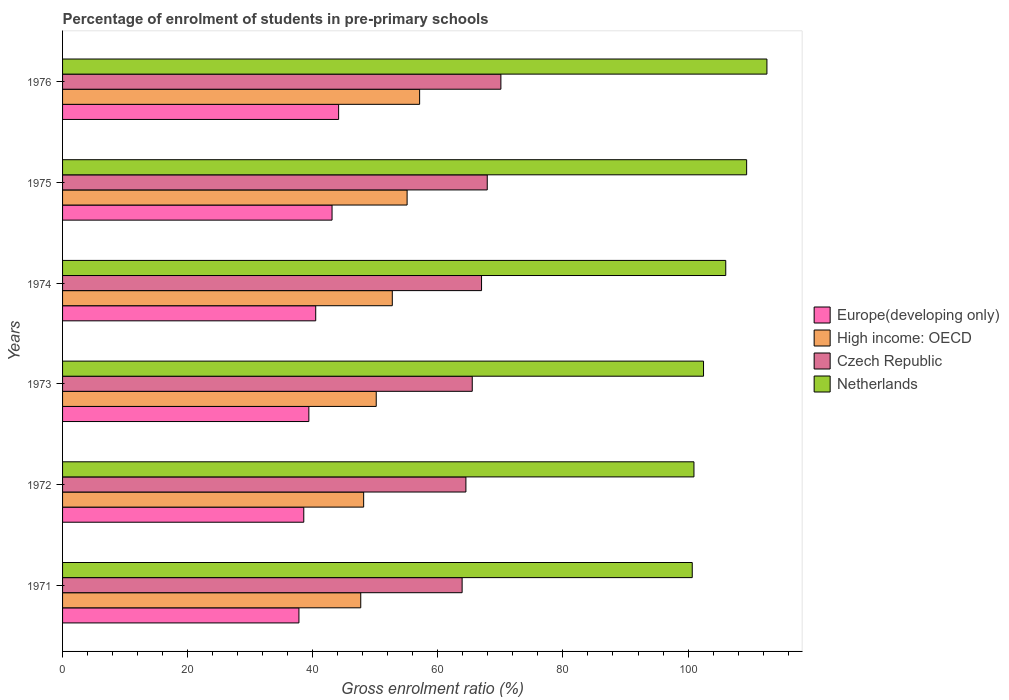How many different coloured bars are there?
Offer a very short reply. 4. How many groups of bars are there?
Your answer should be very brief. 6. Are the number of bars on each tick of the Y-axis equal?
Your answer should be compact. Yes. How many bars are there on the 4th tick from the bottom?
Your response must be concise. 4. What is the percentage of students enrolled in pre-primary schools in Europe(developing only) in 1972?
Offer a terse response. 38.57. Across all years, what is the maximum percentage of students enrolled in pre-primary schools in Czech Republic?
Your answer should be compact. 70.08. Across all years, what is the minimum percentage of students enrolled in pre-primary schools in Europe(developing only)?
Offer a terse response. 37.79. In which year was the percentage of students enrolled in pre-primary schools in Netherlands maximum?
Keep it short and to the point. 1976. In which year was the percentage of students enrolled in pre-primary schools in Europe(developing only) minimum?
Provide a succinct answer. 1971. What is the total percentage of students enrolled in pre-primary schools in Czech Republic in the graph?
Keep it short and to the point. 398.83. What is the difference between the percentage of students enrolled in pre-primary schools in Czech Republic in 1973 and that in 1976?
Your answer should be very brief. -4.58. What is the difference between the percentage of students enrolled in pre-primary schools in Netherlands in 1973 and the percentage of students enrolled in pre-primary schools in High income: OECD in 1974?
Give a very brief answer. 49.76. What is the average percentage of students enrolled in pre-primary schools in High income: OECD per year?
Offer a very short reply. 51.81. In the year 1974, what is the difference between the percentage of students enrolled in pre-primary schools in High income: OECD and percentage of students enrolled in pre-primary schools in Czech Republic?
Provide a short and direct response. -14.27. In how many years, is the percentage of students enrolled in pre-primary schools in Netherlands greater than 12 %?
Your answer should be compact. 6. What is the ratio of the percentage of students enrolled in pre-primary schools in Czech Republic in 1972 to that in 1975?
Ensure brevity in your answer.  0.95. What is the difference between the highest and the second highest percentage of students enrolled in pre-primary schools in Netherlands?
Provide a short and direct response. 3.24. What is the difference between the highest and the lowest percentage of students enrolled in pre-primary schools in Netherlands?
Provide a succinct answer. 11.94. Is the sum of the percentage of students enrolled in pre-primary schools in Netherlands in 1972 and 1975 greater than the maximum percentage of students enrolled in pre-primary schools in Czech Republic across all years?
Your answer should be very brief. Yes. What does the 1st bar from the top in 1974 represents?
Offer a terse response. Netherlands. Is it the case that in every year, the sum of the percentage of students enrolled in pre-primary schools in Europe(developing only) and percentage of students enrolled in pre-primary schools in High income: OECD is greater than the percentage of students enrolled in pre-primary schools in Netherlands?
Your response must be concise. No. How many bars are there?
Provide a succinct answer. 24. What is the difference between two consecutive major ticks on the X-axis?
Offer a terse response. 20. Does the graph contain any zero values?
Your answer should be compact. No. Does the graph contain grids?
Your response must be concise. No. Where does the legend appear in the graph?
Keep it short and to the point. Center right. What is the title of the graph?
Make the answer very short. Percentage of enrolment of students in pre-primary schools. What is the label or title of the Y-axis?
Your answer should be compact. Years. What is the Gross enrolment ratio (%) in Europe(developing only) in 1971?
Your response must be concise. 37.79. What is the Gross enrolment ratio (%) of High income: OECD in 1971?
Offer a very short reply. 47.67. What is the Gross enrolment ratio (%) in Czech Republic in 1971?
Give a very brief answer. 63.88. What is the Gross enrolment ratio (%) of Netherlands in 1971?
Keep it short and to the point. 100.67. What is the Gross enrolment ratio (%) of Europe(developing only) in 1972?
Offer a terse response. 38.57. What is the Gross enrolment ratio (%) of High income: OECD in 1972?
Offer a terse response. 48.14. What is the Gross enrolment ratio (%) of Czech Republic in 1972?
Keep it short and to the point. 64.48. What is the Gross enrolment ratio (%) of Netherlands in 1972?
Provide a short and direct response. 100.94. What is the Gross enrolment ratio (%) of Europe(developing only) in 1973?
Make the answer very short. 39.38. What is the Gross enrolment ratio (%) in High income: OECD in 1973?
Your response must be concise. 50.15. What is the Gross enrolment ratio (%) in Czech Republic in 1973?
Provide a short and direct response. 65.5. What is the Gross enrolment ratio (%) of Netherlands in 1973?
Offer a terse response. 102.47. What is the Gross enrolment ratio (%) in Europe(developing only) in 1974?
Your answer should be compact. 40.47. What is the Gross enrolment ratio (%) in High income: OECD in 1974?
Your answer should be compact. 52.72. What is the Gross enrolment ratio (%) of Czech Republic in 1974?
Your response must be concise. 66.99. What is the Gross enrolment ratio (%) of Netherlands in 1974?
Ensure brevity in your answer.  106.03. What is the Gross enrolment ratio (%) of Europe(developing only) in 1975?
Offer a terse response. 43.08. What is the Gross enrolment ratio (%) of High income: OECD in 1975?
Provide a short and direct response. 55.08. What is the Gross enrolment ratio (%) of Czech Republic in 1975?
Your answer should be compact. 67.9. What is the Gross enrolment ratio (%) in Netherlands in 1975?
Your answer should be compact. 109.37. What is the Gross enrolment ratio (%) of Europe(developing only) in 1976?
Ensure brevity in your answer.  44.14. What is the Gross enrolment ratio (%) in High income: OECD in 1976?
Give a very brief answer. 57.09. What is the Gross enrolment ratio (%) of Czech Republic in 1976?
Provide a short and direct response. 70.08. What is the Gross enrolment ratio (%) of Netherlands in 1976?
Make the answer very short. 112.61. Across all years, what is the maximum Gross enrolment ratio (%) in Europe(developing only)?
Offer a terse response. 44.14. Across all years, what is the maximum Gross enrolment ratio (%) in High income: OECD?
Offer a very short reply. 57.09. Across all years, what is the maximum Gross enrolment ratio (%) of Czech Republic?
Make the answer very short. 70.08. Across all years, what is the maximum Gross enrolment ratio (%) of Netherlands?
Offer a very short reply. 112.61. Across all years, what is the minimum Gross enrolment ratio (%) of Europe(developing only)?
Offer a terse response. 37.79. Across all years, what is the minimum Gross enrolment ratio (%) of High income: OECD?
Give a very brief answer. 47.67. Across all years, what is the minimum Gross enrolment ratio (%) of Czech Republic?
Your answer should be very brief. 63.88. Across all years, what is the minimum Gross enrolment ratio (%) of Netherlands?
Provide a succinct answer. 100.67. What is the total Gross enrolment ratio (%) in Europe(developing only) in the graph?
Ensure brevity in your answer.  243.43. What is the total Gross enrolment ratio (%) of High income: OECD in the graph?
Provide a short and direct response. 310.85. What is the total Gross enrolment ratio (%) of Czech Republic in the graph?
Your response must be concise. 398.83. What is the total Gross enrolment ratio (%) of Netherlands in the graph?
Offer a very short reply. 632.09. What is the difference between the Gross enrolment ratio (%) of Europe(developing only) in 1971 and that in 1972?
Give a very brief answer. -0.78. What is the difference between the Gross enrolment ratio (%) in High income: OECD in 1971 and that in 1972?
Your answer should be compact. -0.47. What is the difference between the Gross enrolment ratio (%) of Czech Republic in 1971 and that in 1972?
Make the answer very short. -0.6. What is the difference between the Gross enrolment ratio (%) of Netherlands in 1971 and that in 1972?
Offer a terse response. -0.27. What is the difference between the Gross enrolment ratio (%) in Europe(developing only) in 1971 and that in 1973?
Keep it short and to the point. -1.59. What is the difference between the Gross enrolment ratio (%) of High income: OECD in 1971 and that in 1973?
Provide a short and direct response. -2.48. What is the difference between the Gross enrolment ratio (%) in Czech Republic in 1971 and that in 1973?
Provide a succinct answer. -1.62. What is the difference between the Gross enrolment ratio (%) in Netherlands in 1971 and that in 1973?
Offer a very short reply. -1.8. What is the difference between the Gross enrolment ratio (%) in Europe(developing only) in 1971 and that in 1974?
Your answer should be compact. -2.68. What is the difference between the Gross enrolment ratio (%) of High income: OECD in 1971 and that in 1974?
Your answer should be compact. -5.04. What is the difference between the Gross enrolment ratio (%) of Czech Republic in 1971 and that in 1974?
Ensure brevity in your answer.  -3.11. What is the difference between the Gross enrolment ratio (%) in Netherlands in 1971 and that in 1974?
Offer a very short reply. -5.36. What is the difference between the Gross enrolment ratio (%) in Europe(developing only) in 1971 and that in 1975?
Your response must be concise. -5.3. What is the difference between the Gross enrolment ratio (%) of High income: OECD in 1971 and that in 1975?
Give a very brief answer. -7.41. What is the difference between the Gross enrolment ratio (%) in Czech Republic in 1971 and that in 1975?
Keep it short and to the point. -4.02. What is the difference between the Gross enrolment ratio (%) in Netherlands in 1971 and that in 1975?
Offer a terse response. -8.7. What is the difference between the Gross enrolment ratio (%) of Europe(developing only) in 1971 and that in 1976?
Give a very brief answer. -6.35. What is the difference between the Gross enrolment ratio (%) of High income: OECD in 1971 and that in 1976?
Provide a short and direct response. -9.41. What is the difference between the Gross enrolment ratio (%) in Czech Republic in 1971 and that in 1976?
Make the answer very short. -6.2. What is the difference between the Gross enrolment ratio (%) in Netherlands in 1971 and that in 1976?
Provide a short and direct response. -11.94. What is the difference between the Gross enrolment ratio (%) of Europe(developing only) in 1972 and that in 1973?
Provide a succinct answer. -0.81. What is the difference between the Gross enrolment ratio (%) of High income: OECD in 1972 and that in 1973?
Offer a terse response. -2.01. What is the difference between the Gross enrolment ratio (%) in Czech Republic in 1972 and that in 1973?
Provide a succinct answer. -1.02. What is the difference between the Gross enrolment ratio (%) of Netherlands in 1972 and that in 1973?
Provide a short and direct response. -1.53. What is the difference between the Gross enrolment ratio (%) of Europe(developing only) in 1972 and that in 1974?
Your answer should be very brief. -1.91. What is the difference between the Gross enrolment ratio (%) in High income: OECD in 1972 and that in 1974?
Provide a short and direct response. -4.58. What is the difference between the Gross enrolment ratio (%) in Czech Republic in 1972 and that in 1974?
Provide a short and direct response. -2.5. What is the difference between the Gross enrolment ratio (%) in Netherlands in 1972 and that in 1974?
Offer a very short reply. -5.08. What is the difference between the Gross enrolment ratio (%) in Europe(developing only) in 1972 and that in 1975?
Your response must be concise. -4.52. What is the difference between the Gross enrolment ratio (%) of High income: OECD in 1972 and that in 1975?
Your answer should be very brief. -6.95. What is the difference between the Gross enrolment ratio (%) of Czech Republic in 1972 and that in 1975?
Provide a succinct answer. -3.41. What is the difference between the Gross enrolment ratio (%) of Netherlands in 1972 and that in 1975?
Give a very brief answer. -8.42. What is the difference between the Gross enrolment ratio (%) of Europe(developing only) in 1972 and that in 1976?
Your answer should be very brief. -5.57. What is the difference between the Gross enrolment ratio (%) in High income: OECD in 1972 and that in 1976?
Give a very brief answer. -8.95. What is the difference between the Gross enrolment ratio (%) of Czech Republic in 1972 and that in 1976?
Your answer should be compact. -5.59. What is the difference between the Gross enrolment ratio (%) in Netherlands in 1972 and that in 1976?
Keep it short and to the point. -11.67. What is the difference between the Gross enrolment ratio (%) in Europe(developing only) in 1973 and that in 1974?
Ensure brevity in your answer.  -1.1. What is the difference between the Gross enrolment ratio (%) of High income: OECD in 1973 and that in 1974?
Keep it short and to the point. -2.57. What is the difference between the Gross enrolment ratio (%) of Czech Republic in 1973 and that in 1974?
Offer a very short reply. -1.49. What is the difference between the Gross enrolment ratio (%) of Netherlands in 1973 and that in 1974?
Ensure brevity in your answer.  -3.55. What is the difference between the Gross enrolment ratio (%) in Europe(developing only) in 1973 and that in 1975?
Give a very brief answer. -3.71. What is the difference between the Gross enrolment ratio (%) in High income: OECD in 1973 and that in 1975?
Provide a succinct answer. -4.94. What is the difference between the Gross enrolment ratio (%) of Czech Republic in 1973 and that in 1975?
Keep it short and to the point. -2.4. What is the difference between the Gross enrolment ratio (%) in Netherlands in 1973 and that in 1975?
Your answer should be very brief. -6.89. What is the difference between the Gross enrolment ratio (%) in Europe(developing only) in 1973 and that in 1976?
Your answer should be very brief. -4.76. What is the difference between the Gross enrolment ratio (%) in High income: OECD in 1973 and that in 1976?
Give a very brief answer. -6.94. What is the difference between the Gross enrolment ratio (%) of Czech Republic in 1973 and that in 1976?
Provide a succinct answer. -4.58. What is the difference between the Gross enrolment ratio (%) of Netherlands in 1973 and that in 1976?
Ensure brevity in your answer.  -10.13. What is the difference between the Gross enrolment ratio (%) of Europe(developing only) in 1974 and that in 1975?
Offer a terse response. -2.61. What is the difference between the Gross enrolment ratio (%) of High income: OECD in 1974 and that in 1975?
Ensure brevity in your answer.  -2.37. What is the difference between the Gross enrolment ratio (%) in Czech Republic in 1974 and that in 1975?
Keep it short and to the point. -0.91. What is the difference between the Gross enrolment ratio (%) of Netherlands in 1974 and that in 1975?
Offer a terse response. -3.34. What is the difference between the Gross enrolment ratio (%) of Europe(developing only) in 1974 and that in 1976?
Keep it short and to the point. -3.66. What is the difference between the Gross enrolment ratio (%) in High income: OECD in 1974 and that in 1976?
Offer a very short reply. -4.37. What is the difference between the Gross enrolment ratio (%) of Czech Republic in 1974 and that in 1976?
Ensure brevity in your answer.  -3.09. What is the difference between the Gross enrolment ratio (%) in Netherlands in 1974 and that in 1976?
Make the answer very short. -6.58. What is the difference between the Gross enrolment ratio (%) in Europe(developing only) in 1975 and that in 1976?
Keep it short and to the point. -1.05. What is the difference between the Gross enrolment ratio (%) in High income: OECD in 1975 and that in 1976?
Give a very brief answer. -2. What is the difference between the Gross enrolment ratio (%) of Czech Republic in 1975 and that in 1976?
Offer a very short reply. -2.18. What is the difference between the Gross enrolment ratio (%) in Netherlands in 1975 and that in 1976?
Make the answer very short. -3.24. What is the difference between the Gross enrolment ratio (%) in Europe(developing only) in 1971 and the Gross enrolment ratio (%) in High income: OECD in 1972?
Provide a short and direct response. -10.35. What is the difference between the Gross enrolment ratio (%) in Europe(developing only) in 1971 and the Gross enrolment ratio (%) in Czech Republic in 1972?
Provide a short and direct response. -26.7. What is the difference between the Gross enrolment ratio (%) of Europe(developing only) in 1971 and the Gross enrolment ratio (%) of Netherlands in 1972?
Make the answer very short. -63.15. What is the difference between the Gross enrolment ratio (%) in High income: OECD in 1971 and the Gross enrolment ratio (%) in Czech Republic in 1972?
Your response must be concise. -16.81. What is the difference between the Gross enrolment ratio (%) in High income: OECD in 1971 and the Gross enrolment ratio (%) in Netherlands in 1972?
Provide a succinct answer. -53.27. What is the difference between the Gross enrolment ratio (%) in Czech Republic in 1971 and the Gross enrolment ratio (%) in Netherlands in 1972?
Keep it short and to the point. -37.06. What is the difference between the Gross enrolment ratio (%) in Europe(developing only) in 1971 and the Gross enrolment ratio (%) in High income: OECD in 1973?
Your answer should be very brief. -12.36. What is the difference between the Gross enrolment ratio (%) in Europe(developing only) in 1971 and the Gross enrolment ratio (%) in Czech Republic in 1973?
Keep it short and to the point. -27.71. What is the difference between the Gross enrolment ratio (%) of Europe(developing only) in 1971 and the Gross enrolment ratio (%) of Netherlands in 1973?
Give a very brief answer. -64.69. What is the difference between the Gross enrolment ratio (%) of High income: OECD in 1971 and the Gross enrolment ratio (%) of Czech Republic in 1973?
Keep it short and to the point. -17.83. What is the difference between the Gross enrolment ratio (%) in High income: OECD in 1971 and the Gross enrolment ratio (%) in Netherlands in 1973?
Keep it short and to the point. -54.8. What is the difference between the Gross enrolment ratio (%) in Czech Republic in 1971 and the Gross enrolment ratio (%) in Netherlands in 1973?
Ensure brevity in your answer.  -38.59. What is the difference between the Gross enrolment ratio (%) in Europe(developing only) in 1971 and the Gross enrolment ratio (%) in High income: OECD in 1974?
Your answer should be very brief. -14.93. What is the difference between the Gross enrolment ratio (%) of Europe(developing only) in 1971 and the Gross enrolment ratio (%) of Czech Republic in 1974?
Keep it short and to the point. -29.2. What is the difference between the Gross enrolment ratio (%) of Europe(developing only) in 1971 and the Gross enrolment ratio (%) of Netherlands in 1974?
Keep it short and to the point. -68.24. What is the difference between the Gross enrolment ratio (%) in High income: OECD in 1971 and the Gross enrolment ratio (%) in Czech Republic in 1974?
Give a very brief answer. -19.31. What is the difference between the Gross enrolment ratio (%) of High income: OECD in 1971 and the Gross enrolment ratio (%) of Netherlands in 1974?
Ensure brevity in your answer.  -58.35. What is the difference between the Gross enrolment ratio (%) of Czech Republic in 1971 and the Gross enrolment ratio (%) of Netherlands in 1974?
Make the answer very short. -42.15. What is the difference between the Gross enrolment ratio (%) of Europe(developing only) in 1971 and the Gross enrolment ratio (%) of High income: OECD in 1975?
Your response must be concise. -17.3. What is the difference between the Gross enrolment ratio (%) in Europe(developing only) in 1971 and the Gross enrolment ratio (%) in Czech Republic in 1975?
Provide a short and direct response. -30.11. What is the difference between the Gross enrolment ratio (%) of Europe(developing only) in 1971 and the Gross enrolment ratio (%) of Netherlands in 1975?
Ensure brevity in your answer.  -71.58. What is the difference between the Gross enrolment ratio (%) in High income: OECD in 1971 and the Gross enrolment ratio (%) in Czech Republic in 1975?
Keep it short and to the point. -20.22. What is the difference between the Gross enrolment ratio (%) of High income: OECD in 1971 and the Gross enrolment ratio (%) of Netherlands in 1975?
Keep it short and to the point. -61.69. What is the difference between the Gross enrolment ratio (%) of Czech Republic in 1971 and the Gross enrolment ratio (%) of Netherlands in 1975?
Provide a short and direct response. -45.49. What is the difference between the Gross enrolment ratio (%) of Europe(developing only) in 1971 and the Gross enrolment ratio (%) of High income: OECD in 1976?
Offer a very short reply. -19.3. What is the difference between the Gross enrolment ratio (%) of Europe(developing only) in 1971 and the Gross enrolment ratio (%) of Czech Republic in 1976?
Give a very brief answer. -32.29. What is the difference between the Gross enrolment ratio (%) of Europe(developing only) in 1971 and the Gross enrolment ratio (%) of Netherlands in 1976?
Your response must be concise. -74.82. What is the difference between the Gross enrolment ratio (%) of High income: OECD in 1971 and the Gross enrolment ratio (%) of Czech Republic in 1976?
Give a very brief answer. -22.41. What is the difference between the Gross enrolment ratio (%) of High income: OECD in 1971 and the Gross enrolment ratio (%) of Netherlands in 1976?
Offer a terse response. -64.94. What is the difference between the Gross enrolment ratio (%) of Czech Republic in 1971 and the Gross enrolment ratio (%) of Netherlands in 1976?
Provide a short and direct response. -48.73. What is the difference between the Gross enrolment ratio (%) in Europe(developing only) in 1972 and the Gross enrolment ratio (%) in High income: OECD in 1973?
Provide a succinct answer. -11.58. What is the difference between the Gross enrolment ratio (%) of Europe(developing only) in 1972 and the Gross enrolment ratio (%) of Czech Republic in 1973?
Keep it short and to the point. -26.93. What is the difference between the Gross enrolment ratio (%) in Europe(developing only) in 1972 and the Gross enrolment ratio (%) in Netherlands in 1973?
Keep it short and to the point. -63.91. What is the difference between the Gross enrolment ratio (%) in High income: OECD in 1972 and the Gross enrolment ratio (%) in Czech Republic in 1973?
Your answer should be very brief. -17.36. What is the difference between the Gross enrolment ratio (%) in High income: OECD in 1972 and the Gross enrolment ratio (%) in Netherlands in 1973?
Ensure brevity in your answer.  -54.34. What is the difference between the Gross enrolment ratio (%) in Czech Republic in 1972 and the Gross enrolment ratio (%) in Netherlands in 1973?
Offer a very short reply. -37.99. What is the difference between the Gross enrolment ratio (%) of Europe(developing only) in 1972 and the Gross enrolment ratio (%) of High income: OECD in 1974?
Keep it short and to the point. -14.15. What is the difference between the Gross enrolment ratio (%) in Europe(developing only) in 1972 and the Gross enrolment ratio (%) in Czech Republic in 1974?
Make the answer very short. -28.42. What is the difference between the Gross enrolment ratio (%) of Europe(developing only) in 1972 and the Gross enrolment ratio (%) of Netherlands in 1974?
Give a very brief answer. -67.46. What is the difference between the Gross enrolment ratio (%) of High income: OECD in 1972 and the Gross enrolment ratio (%) of Czech Republic in 1974?
Give a very brief answer. -18.85. What is the difference between the Gross enrolment ratio (%) in High income: OECD in 1972 and the Gross enrolment ratio (%) in Netherlands in 1974?
Provide a succinct answer. -57.89. What is the difference between the Gross enrolment ratio (%) of Czech Republic in 1972 and the Gross enrolment ratio (%) of Netherlands in 1974?
Your answer should be compact. -41.54. What is the difference between the Gross enrolment ratio (%) of Europe(developing only) in 1972 and the Gross enrolment ratio (%) of High income: OECD in 1975?
Keep it short and to the point. -16.52. What is the difference between the Gross enrolment ratio (%) in Europe(developing only) in 1972 and the Gross enrolment ratio (%) in Czech Republic in 1975?
Ensure brevity in your answer.  -29.33. What is the difference between the Gross enrolment ratio (%) in Europe(developing only) in 1972 and the Gross enrolment ratio (%) in Netherlands in 1975?
Offer a very short reply. -70.8. What is the difference between the Gross enrolment ratio (%) of High income: OECD in 1972 and the Gross enrolment ratio (%) of Czech Republic in 1975?
Offer a terse response. -19.76. What is the difference between the Gross enrolment ratio (%) in High income: OECD in 1972 and the Gross enrolment ratio (%) in Netherlands in 1975?
Offer a terse response. -61.23. What is the difference between the Gross enrolment ratio (%) in Czech Republic in 1972 and the Gross enrolment ratio (%) in Netherlands in 1975?
Offer a terse response. -44.88. What is the difference between the Gross enrolment ratio (%) in Europe(developing only) in 1972 and the Gross enrolment ratio (%) in High income: OECD in 1976?
Offer a very short reply. -18.52. What is the difference between the Gross enrolment ratio (%) in Europe(developing only) in 1972 and the Gross enrolment ratio (%) in Czech Republic in 1976?
Provide a short and direct response. -31.51. What is the difference between the Gross enrolment ratio (%) of Europe(developing only) in 1972 and the Gross enrolment ratio (%) of Netherlands in 1976?
Offer a terse response. -74.04. What is the difference between the Gross enrolment ratio (%) in High income: OECD in 1972 and the Gross enrolment ratio (%) in Czech Republic in 1976?
Offer a very short reply. -21.94. What is the difference between the Gross enrolment ratio (%) in High income: OECD in 1972 and the Gross enrolment ratio (%) in Netherlands in 1976?
Offer a terse response. -64.47. What is the difference between the Gross enrolment ratio (%) in Czech Republic in 1972 and the Gross enrolment ratio (%) in Netherlands in 1976?
Give a very brief answer. -48.13. What is the difference between the Gross enrolment ratio (%) in Europe(developing only) in 1973 and the Gross enrolment ratio (%) in High income: OECD in 1974?
Offer a very short reply. -13.34. What is the difference between the Gross enrolment ratio (%) in Europe(developing only) in 1973 and the Gross enrolment ratio (%) in Czech Republic in 1974?
Offer a terse response. -27.61. What is the difference between the Gross enrolment ratio (%) in Europe(developing only) in 1973 and the Gross enrolment ratio (%) in Netherlands in 1974?
Ensure brevity in your answer.  -66.65. What is the difference between the Gross enrolment ratio (%) in High income: OECD in 1973 and the Gross enrolment ratio (%) in Czech Republic in 1974?
Make the answer very short. -16.84. What is the difference between the Gross enrolment ratio (%) of High income: OECD in 1973 and the Gross enrolment ratio (%) of Netherlands in 1974?
Ensure brevity in your answer.  -55.88. What is the difference between the Gross enrolment ratio (%) of Czech Republic in 1973 and the Gross enrolment ratio (%) of Netherlands in 1974?
Make the answer very short. -40.53. What is the difference between the Gross enrolment ratio (%) of Europe(developing only) in 1973 and the Gross enrolment ratio (%) of High income: OECD in 1975?
Ensure brevity in your answer.  -15.71. What is the difference between the Gross enrolment ratio (%) of Europe(developing only) in 1973 and the Gross enrolment ratio (%) of Czech Republic in 1975?
Your answer should be very brief. -28.52. What is the difference between the Gross enrolment ratio (%) in Europe(developing only) in 1973 and the Gross enrolment ratio (%) in Netherlands in 1975?
Your answer should be compact. -69.99. What is the difference between the Gross enrolment ratio (%) in High income: OECD in 1973 and the Gross enrolment ratio (%) in Czech Republic in 1975?
Provide a short and direct response. -17.75. What is the difference between the Gross enrolment ratio (%) in High income: OECD in 1973 and the Gross enrolment ratio (%) in Netherlands in 1975?
Your response must be concise. -59.22. What is the difference between the Gross enrolment ratio (%) in Czech Republic in 1973 and the Gross enrolment ratio (%) in Netherlands in 1975?
Provide a short and direct response. -43.87. What is the difference between the Gross enrolment ratio (%) in Europe(developing only) in 1973 and the Gross enrolment ratio (%) in High income: OECD in 1976?
Make the answer very short. -17.71. What is the difference between the Gross enrolment ratio (%) in Europe(developing only) in 1973 and the Gross enrolment ratio (%) in Czech Republic in 1976?
Offer a very short reply. -30.7. What is the difference between the Gross enrolment ratio (%) of Europe(developing only) in 1973 and the Gross enrolment ratio (%) of Netherlands in 1976?
Your response must be concise. -73.23. What is the difference between the Gross enrolment ratio (%) of High income: OECD in 1973 and the Gross enrolment ratio (%) of Czech Republic in 1976?
Give a very brief answer. -19.93. What is the difference between the Gross enrolment ratio (%) of High income: OECD in 1973 and the Gross enrolment ratio (%) of Netherlands in 1976?
Ensure brevity in your answer.  -62.46. What is the difference between the Gross enrolment ratio (%) in Czech Republic in 1973 and the Gross enrolment ratio (%) in Netherlands in 1976?
Ensure brevity in your answer.  -47.11. What is the difference between the Gross enrolment ratio (%) in Europe(developing only) in 1974 and the Gross enrolment ratio (%) in High income: OECD in 1975?
Keep it short and to the point. -14.61. What is the difference between the Gross enrolment ratio (%) of Europe(developing only) in 1974 and the Gross enrolment ratio (%) of Czech Republic in 1975?
Offer a terse response. -27.42. What is the difference between the Gross enrolment ratio (%) in Europe(developing only) in 1974 and the Gross enrolment ratio (%) in Netherlands in 1975?
Your answer should be very brief. -68.89. What is the difference between the Gross enrolment ratio (%) of High income: OECD in 1974 and the Gross enrolment ratio (%) of Czech Republic in 1975?
Ensure brevity in your answer.  -15.18. What is the difference between the Gross enrolment ratio (%) of High income: OECD in 1974 and the Gross enrolment ratio (%) of Netherlands in 1975?
Offer a very short reply. -56.65. What is the difference between the Gross enrolment ratio (%) in Czech Republic in 1974 and the Gross enrolment ratio (%) in Netherlands in 1975?
Your answer should be compact. -42.38. What is the difference between the Gross enrolment ratio (%) of Europe(developing only) in 1974 and the Gross enrolment ratio (%) of High income: OECD in 1976?
Provide a short and direct response. -16.61. What is the difference between the Gross enrolment ratio (%) in Europe(developing only) in 1974 and the Gross enrolment ratio (%) in Czech Republic in 1976?
Your answer should be compact. -29.6. What is the difference between the Gross enrolment ratio (%) of Europe(developing only) in 1974 and the Gross enrolment ratio (%) of Netherlands in 1976?
Make the answer very short. -72.14. What is the difference between the Gross enrolment ratio (%) of High income: OECD in 1974 and the Gross enrolment ratio (%) of Czech Republic in 1976?
Your answer should be compact. -17.36. What is the difference between the Gross enrolment ratio (%) of High income: OECD in 1974 and the Gross enrolment ratio (%) of Netherlands in 1976?
Provide a short and direct response. -59.89. What is the difference between the Gross enrolment ratio (%) of Czech Republic in 1974 and the Gross enrolment ratio (%) of Netherlands in 1976?
Make the answer very short. -45.62. What is the difference between the Gross enrolment ratio (%) of Europe(developing only) in 1975 and the Gross enrolment ratio (%) of High income: OECD in 1976?
Ensure brevity in your answer.  -14. What is the difference between the Gross enrolment ratio (%) of Europe(developing only) in 1975 and the Gross enrolment ratio (%) of Czech Republic in 1976?
Offer a very short reply. -26.99. What is the difference between the Gross enrolment ratio (%) in Europe(developing only) in 1975 and the Gross enrolment ratio (%) in Netherlands in 1976?
Provide a succinct answer. -69.52. What is the difference between the Gross enrolment ratio (%) in High income: OECD in 1975 and the Gross enrolment ratio (%) in Czech Republic in 1976?
Provide a succinct answer. -14.99. What is the difference between the Gross enrolment ratio (%) in High income: OECD in 1975 and the Gross enrolment ratio (%) in Netherlands in 1976?
Keep it short and to the point. -57.53. What is the difference between the Gross enrolment ratio (%) in Czech Republic in 1975 and the Gross enrolment ratio (%) in Netherlands in 1976?
Offer a terse response. -44.71. What is the average Gross enrolment ratio (%) of Europe(developing only) per year?
Keep it short and to the point. 40.57. What is the average Gross enrolment ratio (%) of High income: OECD per year?
Give a very brief answer. 51.81. What is the average Gross enrolment ratio (%) of Czech Republic per year?
Offer a very short reply. 66.47. What is the average Gross enrolment ratio (%) of Netherlands per year?
Provide a succinct answer. 105.35. In the year 1971, what is the difference between the Gross enrolment ratio (%) of Europe(developing only) and Gross enrolment ratio (%) of High income: OECD?
Your response must be concise. -9.88. In the year 1971, what is the difference between the Gross enrolment ratio (%) of Europe(developing only) and Gross enrolment ratio (%) of Czech Republic?
Make the answer very short. -26.09. In the year 1971, what is the difference between the Gross enrolment ratio (%) in Europe(developing only) and Gross enrolment ratio (%) in Netherlands?
Provide a short and direct response. -62.88. In the year 1971, what is the difference between the Gross enrolment ratio (%) in High income: OECD and Gross enrolment ratio (%) in Czech Republic?
Keep it short and to the point. -16.21. In the year 1971, what is the difference between the Gross enrolment ratio (%) of High income: OECD and Gross enrolment ratio (%) of Netherlands?
Offer a terse response. -53. In the year 1971, what is the difference between the Gross enrolment ratio (%) in Czech Republic and Gross enrolment ratio (%) in Netherlands?
Provide a short and direct response. -36.79. In the year 1972, what is the difference between the Gross enrolment ratio (%) in Europe(developing only) and Gross enrolment ratio (%) in High income: OECD?
Offer a terse response. -9.57. In the year 1972, what is the difference between the Gross enrolment ratio (%) in Europe(developing only) and Gross enrolment ratio (%) in Czech Republic?
Offer a terse response. -25.92. In the year 1972, what is the difference between the Gross enrolment ratio (%) in Europe(developing only) and Gross enrolment ratio (%) in Netherlands?
Give a very brief answer. -62.38. In the year 1972, what is the difference between the Gross enrolment ratio (%) in High income: OECD and Gross enrolment ratio (%) in Czech Republic?
Give a very brief answer. -16.35. In the year 1972, what is the difference between the Gross enrolment ratio (%) of High income: OECD and Gross enrolment ratio (%) of Netherlands?
Offer a terse response. -52.81. In the year 1972, what is the difference between the Gross enrolment ratio (%) of Czech Republic and Gross enrolment ratio (%) of Netherlands?
Keep it short and to the point. -36.46. In the year 1973, what is the difference between the Gross enrolment ratio (%) of Europe(developing only) and Gross enrolment ratio (%) of High income: OECD?
Make the answer very short. -10.77. In the year 1973, what is the difference between the Gross enrolment ratio (%) of Europe(developing only) and Gross enrolment ratio (%) of Czech Republic?
Ensure brevity in your answer.  -26.12. In the year 1973, what is the difference between the Gross enrolment ratio (%) in Europe(developing only) and Gross enrolment ratio (%) in Netherlands?
Provide a short and direct response. -63.1. In the year 1973, what is the difference between the Gross enrolment ratio (%) of High income: OECD and Gross enrolment ratio (%) of Czech Republic?
Give a very brief answer. -15.35. In the year 1973, what is the difference between the Gross enrolment ratio (%) in High income: OECD and Gross enrolment ratio (%) in Netherlands?
Give a very brief answer. -52.33. In the year 1973, what is the difference between the Gross enrolment ratio (%) in Czech Republic and Gross enrolment ratio (%) in Netherlands?
Make the answer very short. -36.97. In the year 1974, what is the difference between the Gross enrolment ratio (%) in Europe(developing only) and Gross enrolment ratio (%) in High income: OECD?
Offer a very short reply. -12.24. In the year 1974, what is the difference between the Gross enrolment ratio (%) of Europe(developing only) and Gross enrolment ratio (%) of Czech Republic?
Provide a succinct answer. -26.51. In the year 1974, what is the difference between the Gross enrolment ratio (%) in Europe(developing only) and Gross enrolment ratio (%) in Netherlands?
Make the answer very short. -65.55. In the year 1974, what is the difference between the Gross enrolment ratio (%) of High income: OECD and Gross enrolment ratio (%) of Czech Republic?
Make the answer very short. -14.27. In the year 1974, what is the difference between the Gross enrolment ratio (%) in High income: OECD and Gross enrolment ratio (%) in Netherlands?
Give a very brief answer. -53.31. In the year 1974, what is the difference between the Gross enrolment ratio (%) of Czech Republic and Gross enrolment ratio (%) of Netherlands?
Your answer should be compact. -39.04. In the year 1975, what is the difference between the Gross enrolment ratio (%) of Europe(developing only) and Gross enrolment ratio (%) of High income: OECD?
Your answer should be compact. -12. In the year 1975, what is the difference between the Gross enrolment ratio (%) in Europe(developing only) and Gross enrolment ratio (%) in Czech Republic?
Offer a very short reply. -24.81. In the year 1975, what is the difference between the Gross enrolment ratio (%) in Europe(developing only) and Gross enrolment ratio (%) in Netherlands?
Your answer should be compact. -66.28. In the year 1975, what is the difference between the Gross enrolment ratio (%) in High income: OECD and Gross enrolment ratio (%) in Czech Republic?
Give a very brief answer. -12.81. In the year 1975, what is the difference between the Gross enrolment ratio (%) in High income: OECD and Gross enrolment ratio (%) in Netherlands?
Your answer should be very brief. -54.28. In the year 1975, what is the difference between the Gross enrolment ratio (%) in Czech Republic and Gross enrolment ratio (%) in Netherlands?
Keep it short and to the point. -41.47. In the year 1976, what is the difference between the Gross enrolment ratio (%) in Europe(developing only) and Gross enrolment ratio (%) in High income: OECD?
Provide a short and direct response. -12.95. In the year 1976, what is the difference between the Gross enrolment ratio (%) of Europe(developing only) and Gross enrolment ratio (%) of Czech Republic?
Make the answer very short. -25.94. In the year 1976, what is the difference between the Gross enrolment ratio (%) of Europe(developing only) and Gross enrolment ratio (%) of Netherlands?
Your response must be concise. -68.47. In the year 1976, what is the difference between the Gross enrolment ratio (%) of High income: OECD and Gross enrolment ratio (%) of Czech Republic?
Your response must be concise. -12.99. In the year 1976, what is the difference between the Gross enrolment ratio (%) of High income: OECD and Gross enrolment ratio (%) of Netherlands?
Your response must be concise. -55.52. In the year 1976, what is the difference between the Gross enrolment ratio (%) in Czech Republic and Gross enrolment ratio (%) in Netherlands?
Provide a short and direct response. -42.53. What is the ratio of the Gross enrolment ratio (%) of Europe(developing only) in 1971 to that in 1972?
Your answer should be very brief. 0.98. What is the ratio of the Gross enrolment ratio (%) in High income: OECD in 1971 to that in 1972?
Give a very brief answer. 0.99. What is the ratio of the Gross enrolment ratio (%) in Czech Republic in 1971 to that in 1972?
Offer a terse response. 0.99. What is the ratio of the Gross enrolment ratio (%) of Europe(developing only) in 1971 to that in 1973?
Give a very brief answer. 0.96. What is the ratio of the Gross enrolment ratio (%) in High income: OECD in 1971 to that in 1973?
Give a very brief answer. 0.95. What is the ratio of the Gross enrolment ratio (%) of Czech Republic in 1971 to that in 1973?
Your response must be concise. 0.98. What is the ratio of the Gross enrolment ratio (%) in Netherlands in 1971 to that in 1973?
Give a very brief answer. 0.98. What is the ratio of the Gross enrolment ratio (%) of Europe(developing only) in 1971 to that in 1974?
Your answer should be very brief. 0.93. What is the ratio of the Gross enrolment ratio (%) of High income: OECD in 1971 to that in 1974?
Your answer should be compact. 0.9. What is the ratio of the Gross enrolment ratio (%) in Czech Republic in 1971 to that in 1974?
Keep it short and to the point. 0.95. What is the ratio of the Gross enrolment ratio (%) of Netherlands in 1971 to that in 1974?
Offer a terse response. 0.95. What is the ratio of the Gross enrolment ratio (%) in Europe(developing only) in 1971 to that in 1975?
Provide a short and direct response. 0.88. What is the ratio of the Gross enrolment ratio (%) in High income: OECD in 1971 to that in 1975?
Your response must be concise. 0.87. What is the ratio of the Gross enrolment ratio (%) of Czech Republic in 1971 to that in 1975?
Offer a very short reply. 0.94. What is the ratio of the Gross enrolment ratio (%) of Netherlands in 1971 to that in 1975?
Your answer should be very brief. 0.92. What is the ratio of the Gross enrolment ratio (%) in Europe(developing only) in 1971 to that in 1976?
Offer a terse response. 0.86. What is the ratio of the Gross enrolment ratio (%) in High income: OECD in 1971 to that in 1976?
Provide a short and direct response. 0.84. What is the ratio of the Gross enrolment ratio (%) of Czech Republic in 1971 to that in 1976?
Provide a short and direct response. 0.91. What is the ratio of the Gross enrolment ratio (%) in Netherlands in 1971 to that in 1976?
Your response must be concise. 0.89. What is the ratio of the Gross enrolment ratio (%) in Europe(developing only) in 1972 to that in 1973?
Make the answer very short. 0.98. What is the ratio of the Gross enrolment ratio (%) in High income: OECD in 1972 to that in 1973?
Your answer should be compact. 0.96. What is the ratio of the Gross enrolment ratio (%) in Czech Republic in 1972 to that in 1973?
Keep it short and to the point. 0.98. What is the ratio of the Gross enrolment ratio (%) of Netherlands in 1972 to that in 1973?
Provide a succinct answer. 0.99. What is the ratio of the Gross enrolment ratio (%) of Europe(developing only) in 1972 to that in 1974?
Your answer should be compact. 0.95. What is the ratio of the Gross enrolment ratio (%) of High income: OECD in 1972 to that in 1974?
Make the answer very short. 0.91. What is the ratio of the Gross enrolment ratio (%) in Czech Republic in 1972 to that in 1974?
Provide a succinct answer. 0.96. What is the ratio of the Gross enrolment ratio (%) of Netherlands in 1972 to that in 1974?
Offer a terse response. 0.95. What is the ratio of the Gross enrolment ratio (%) in Europe(developing only) in 1972 to that in 1975?
Make the answer very short. 0.9. What is the ratio of the Gross enrolment ratio (%) of High income: OECD in 1972 to that in 1975?
Give a very brief answer. 0.87. What is the ratio of the Gross enrolment ratio (%) of Czech Republic in 1972 to that in 1975?
Provide a short and direct response. 0.95. What is the ratio of the Gross enrolment ratio (%) in Netherlands in 1972 to that in 1975?
Make the answer very short. 0.92. What is the ratio of the Gross enrolment ratio (%) in Europe(developing only) in 1972 to that in 1976?
Ensure brevity in your answer.  0.87. What is the ratio of the Gross enrolment ratio (%) in High income: OECD in 1972 to that in 1976?
Offer a terse response. 0.84. What is the ratio of the Gross enrolment ratio (%) in Czech Republic in 1972 to that in 1976?
Provide a short and direct response. 0.92. What is the ratio of the Gross enrolment ratio (%) of Netherlands in 1972 to that in 1976?
Ensure brevity in your answer.  0.9. What is the ratio of the Gross enrolment ratio (%) of Europe(developing only) in 1973 to that in 1974?
Your answer should be very brief. 0.97. What is the ratio of the Gross enrolment ratio (%) of High income: OECD in 1973 to that in 1974?
Offer a very short reply. 0.95. What is the ratio of the Gross enrolment ratio (%) in Czech Republic in 1973 to that in 1974?
Offer a very short reply. 0.98. What is the ratio of the Gross enrolment ratio (%) in Netherlands in 1973 to that in 1974?
Offer a terse response. 0.97. What is the ratio of the Gross enrolment ratio (%) in Europe(developing only) in 1973 to that in 1975?
Provide a succinct answer. 0.91. What is the ratio of the Gross enrolment ratio (%) of High income: OECD in 1973 to that in 1975?
Ensure brevity in your answer.  0.91. What is the ratio of the Gross enrolment ratio (%) in Czech Republic in 1973 to that in 1975?
Provide a succinct answer. 0.96. What is the ratio of the Gross enrolment ratio (%) in Netherlands in 1973 to that in 1975?
Make the answer very short. 0.94. What is the ratio of the Gross enrolment ratio (%) in Europe(developing only) in 1973 to that in 1976?
Your answer should be compact. 0.89. What is the ratio of the Gross enrolment ratio (%) of High income: OECD in 1973 to that in 1976?
Your answer should be compact. 0.88. What is the ratio of the Gross enrolment ratio (%) of Czech Republic in 1973 to that in 1976?
Your answer should be very brief. 0.93. What is the ratio of the Gross enrolment ratio (%) of Netherlands in 1973 to that in 1976?
Offer a very short reply. 0.91. What is the ratio of the Gross enrolment ratio (%) of Europe(developing only) in 1974 to that in 1975?
Ensure brevity in your answer.  0.94. What is the ratio of the Gross enrolment ratio (%) of High income: OECD in 1974 to that in 1975?
Provide a succinct answer. 0.96. What is the ratio of the Gross enrolment ratio (%) of Czech Republic in 1974 to that in 1975?
Offer a very short reply. 0.99. What is the ratio of the Gross enrolment ratio (%) in Netherlands in 1974 to that in 1975?
Make the answer very short. 0.97. What is the ratio of the Gross enrolment ratio (%) of Europe(developing only) in 1974 to that in 1976?
Provide a succinct answer. 0.92. What is the ratio of the Gross enrolment ratio (%) in High income: OECD in 1974 to that in 1976?
Your answer should be compact. 0.92. What is the ratio of the Gross enrolment ratio (%) in Czech Republic in 1974 to that in 1976?
Your response must be concise. 0.96. What is the ratio of the Gross enrolment ratio (%) of Netherlands in 1974 to that in 1976?
Your answer should be very brief. 0.94. What is the ratio of the Gross enrolment ratio (%) of Europe(developing only) in 1975 to that in 1976?
Ensure brevity in your answer.  0.98. What is the ratio of the Gross enrolment ratio (%) in High income: OECD in 1975 to that in 1976?
Keep it short and to the point. 0.96. What is the ratio of the Gross enrolment ratio (%) of Czech Republic in 1975 to that in 1976?
Your response must be concise. 0.97. What is the ratio of the Gross enrolment ratio (%) in Netherlands in 1975 to that in 1976?
Your answer should be compact. 0.97. What is the difference between the highest and the second highest Gross enrolment ratio (%) in Europe(developing only)?
Keep it short and to the point. 1.05. What is the difference between the highest and the second highest Gross enrolment ratio (%) in High income: OECD?
Provide a short and direct response. 2. What is the difference between the highest and the second highest Gross enrolment ratio (%) of Czech Republic?
Make the answer very short. 2.18. What is the difference between the highest and the second highest Gross enrolment ratio (%) in Netherlands?
Offer a very short reply. 3.24. What is the difference between the highest and the lowest Gross enrolment ratio (%) of Europe(developing only)?
Your response must be concise. 6.35. What is the difference between the highest and the lowest Gross enrolment ratio (%) in High income: OECD?
Your response must be concise. 9.41. What is the difference between the highest and the lowest Gross enrolment ratio (%) of Czech Republic?
Keep it short and to the point. 6.2. What is the difference between the highest and the lowest Gross enrolment ratio (%) of Netherlands?
Your answer should be compact. 11.94. 